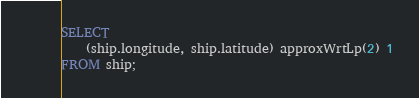<code> <loc_0><loc_0><loc_500><loc_500><_SQL_>SELECT
    (ship.longitude, ship.latitude) approxWrtLp(2) 1
FROM ship;
</code> 